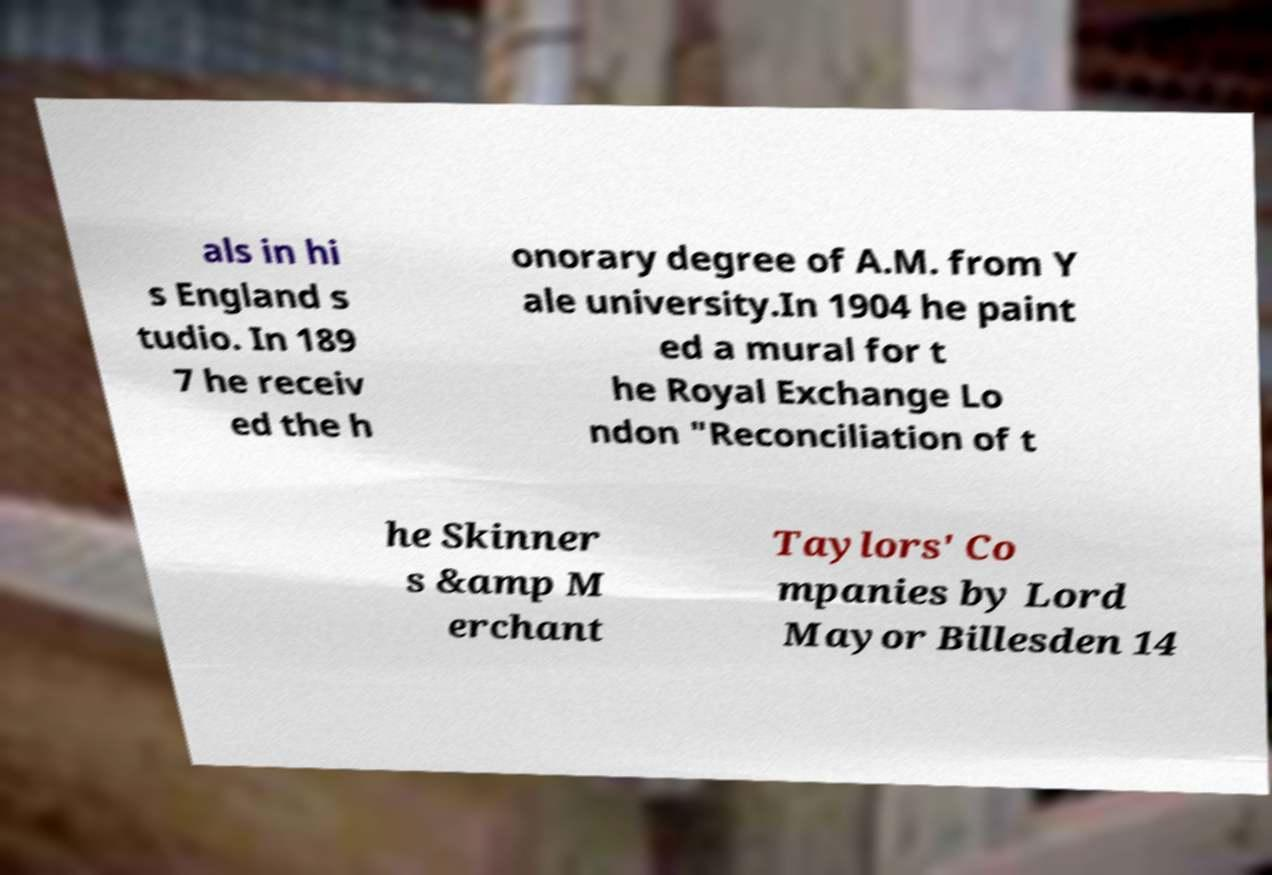What messages or text are displayed in this image? I need them in a readable, typed format. als in hi s England s tudio. In 189 7 he receiv ed the h onorary degree of A.M. from Y ale university.In 1904 he paint ed a mural for t he Royal Exchange Lo ndon "Reconciliation of t he Skinner s &amp M erchant Taylors' Co mpanies by Lord Mayor Billesden 14 